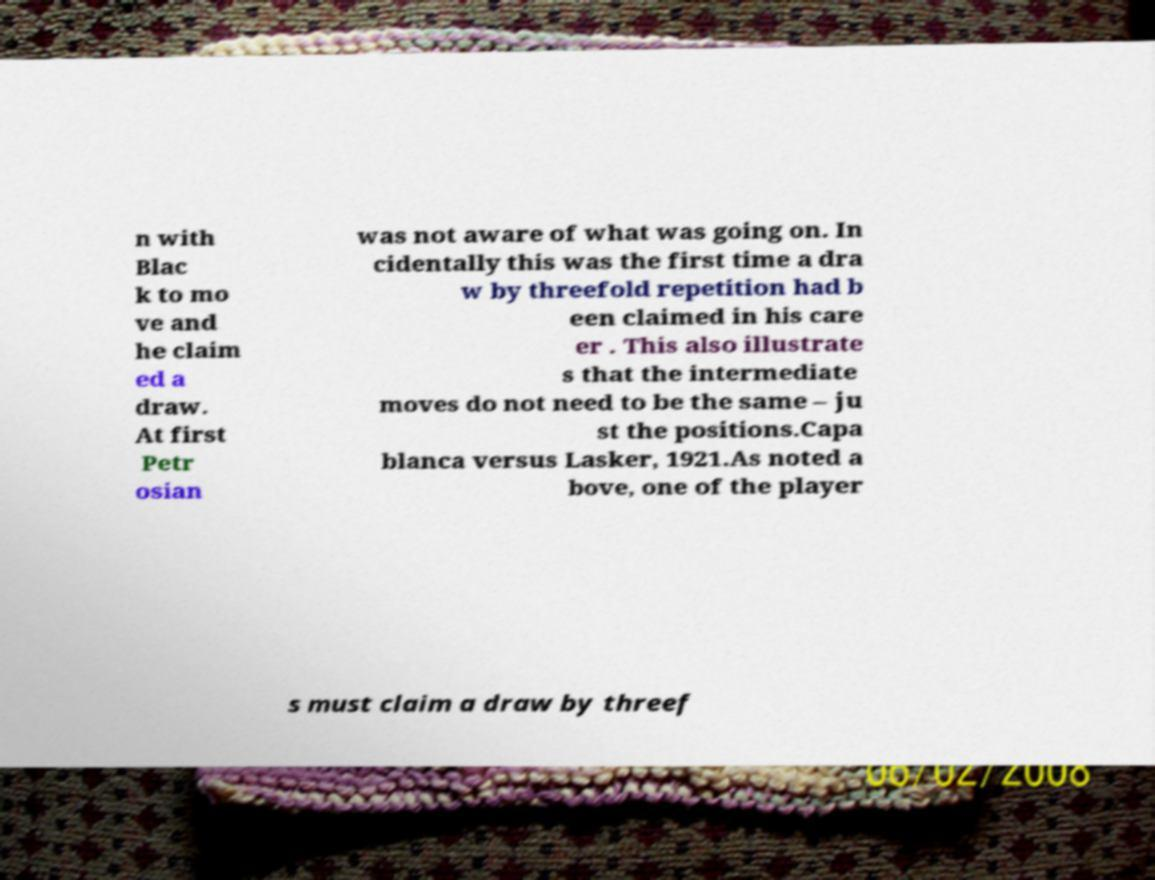Could you extract and type out the text from this image? n with Blac k to mo ve and he claim ed a draw. At first Petr osian was not aware of what was going on. In cidentally this was the first time a dra w by threefold repetition had b een claimed in his care er . This also illustrate s that the intermediate moves do not need to be the same – ju st the positions.Capa blanca versus Lasker, 1921.As noted a bove, one of the player s must claim a draw by threef 